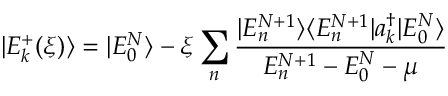<formula> <loc_0><loc_0><loc_500><loc_500>| E _ { k } ^ { + } ( \xi ) \rangle = | E _ { 0 } ^ { N } \rangle - \xi \sum _ { n } \frac { | E _ { n } ^ { N + 1 } \rangle \langle E _ { n } ^ { N + 1 } | a _ { k } ^ { \dagger } | E _ { 0 } ^ { N } \rangle } { E _ { n } ^ { N + 1 } - E _ { 0 } ^ { N } - \mu }</formula> 